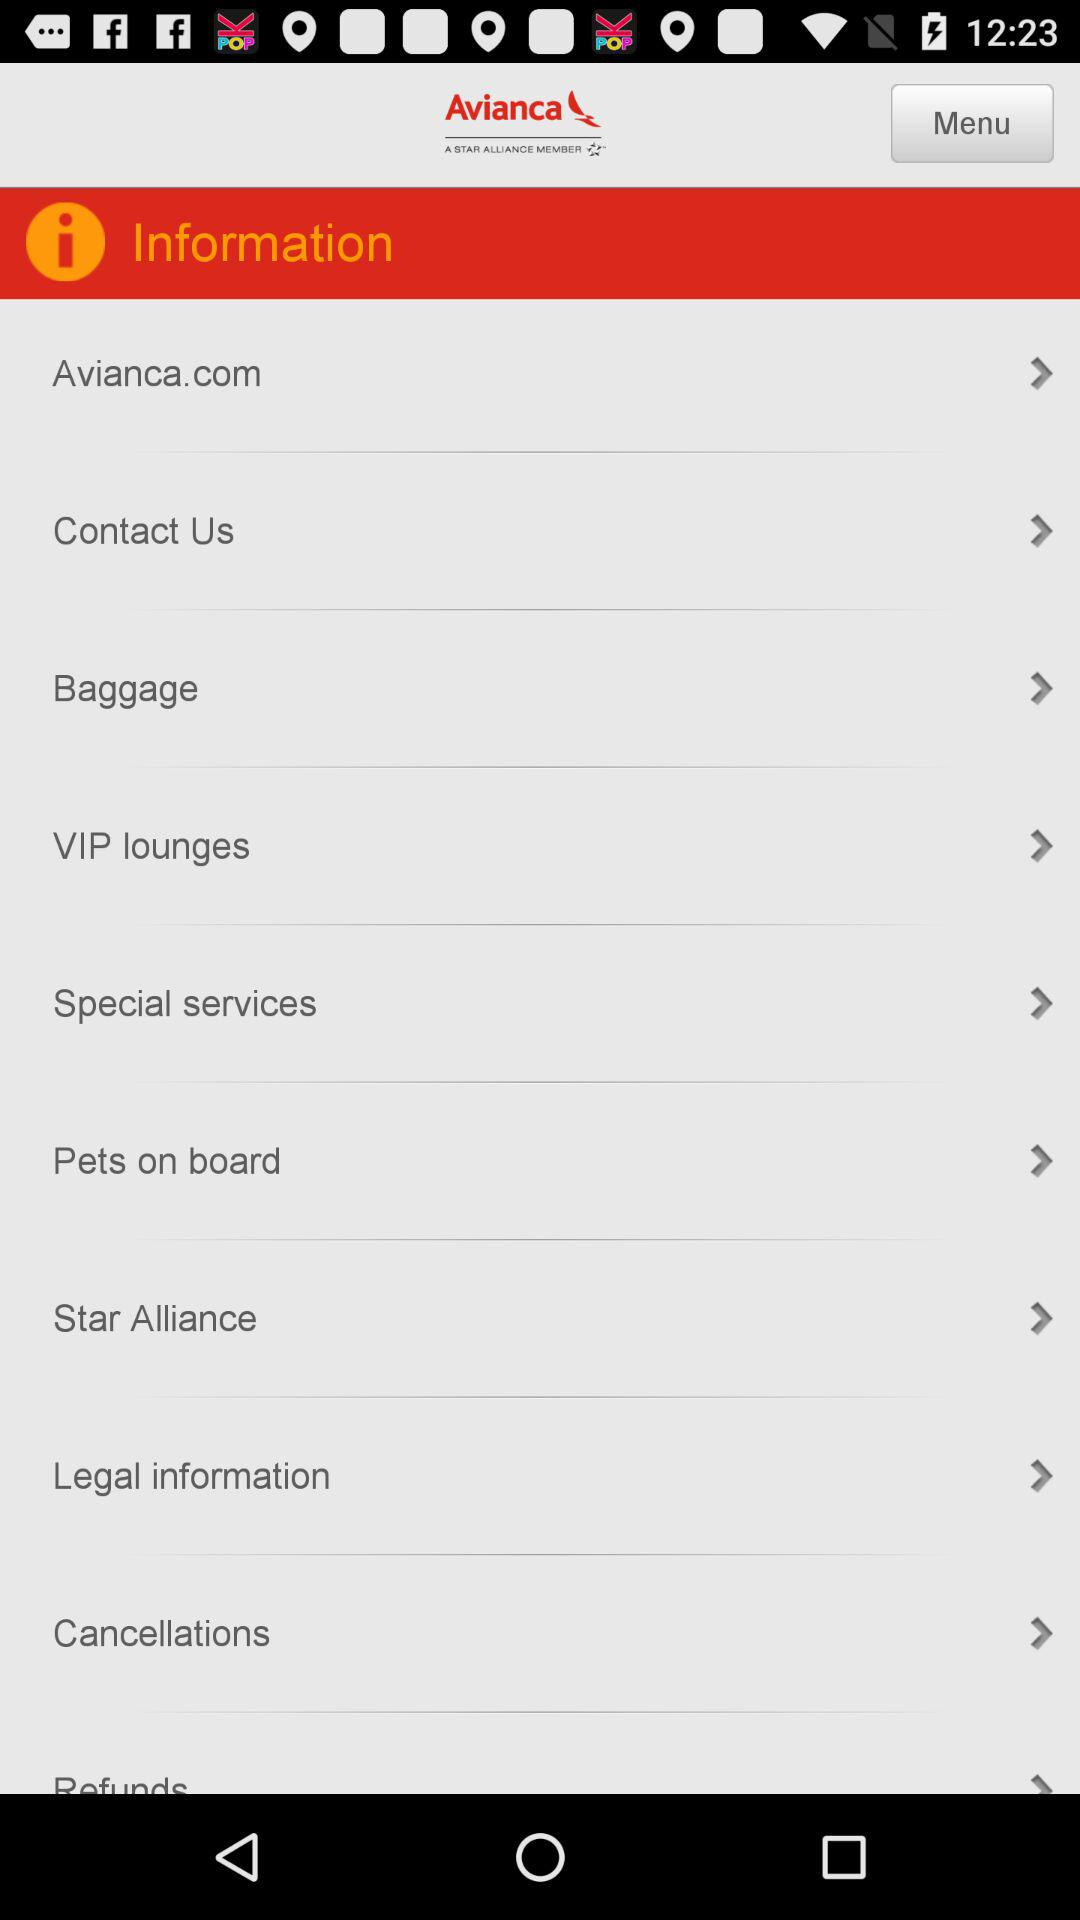What is the name of the application? The name of the application is "Avianca". 